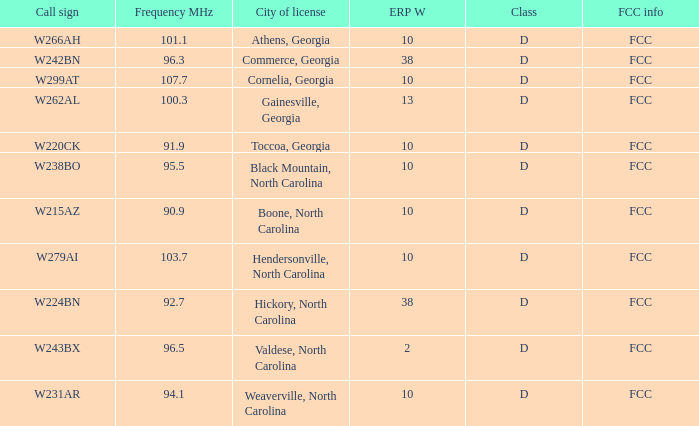Could you help me parse every detail presented in this table? {'header': ['Call sign', 'Frequency MHz', 'City of license', 'ERP W', 'Class', 'FCC info'], 'rows': [['W266AH', '101.1', 'Athens, Georgia', '10', 'D', 'FCC'], ['W242BN', '96.3', 'Commerce, Georgia', '38', 'D', 'FCC'], ['W299AT', '107.7', 'Cornelia, Georgia', '10', 'D', 'FCC'], ['W262AL', '100.3', 'Gainesville, Georgia', '13', 'D', 'FCC'], ['W220CK', '91.9', 'Toccoa, Georgia', '10', 'D', 'FCC'], ['W238BO', '95.5', 'Black Mountain, North Carolina', '10', 'D', 'FCC'], ['W215AZ', '90.9', 'Boone, North Carolina', '10', 'D', 'FCC'], ['W279AI', '103.7', 'Hendersonville, North Carolina', '10', 'D', 'FCC'], ['W224BN', '92.7', 'Hickory, North Carolina', '38', 'D', 'FCC'], ['W243BX', '96.5', 'Valdese, North Carolina', '2', 'D', 'FCC'], ['W231AR', '94.1', 'Weaverville, North Carolina', '10', 'D', 'FCC']]} What city has larger than 94.1 as a frequency? Athens, Georgia, Commerce, Georgia, Cornelia, Georgia, Gainesville, Georgia, Black Mountain, North Carolina, Hendersonville, North Carolina, Valdese, North Carolina. 